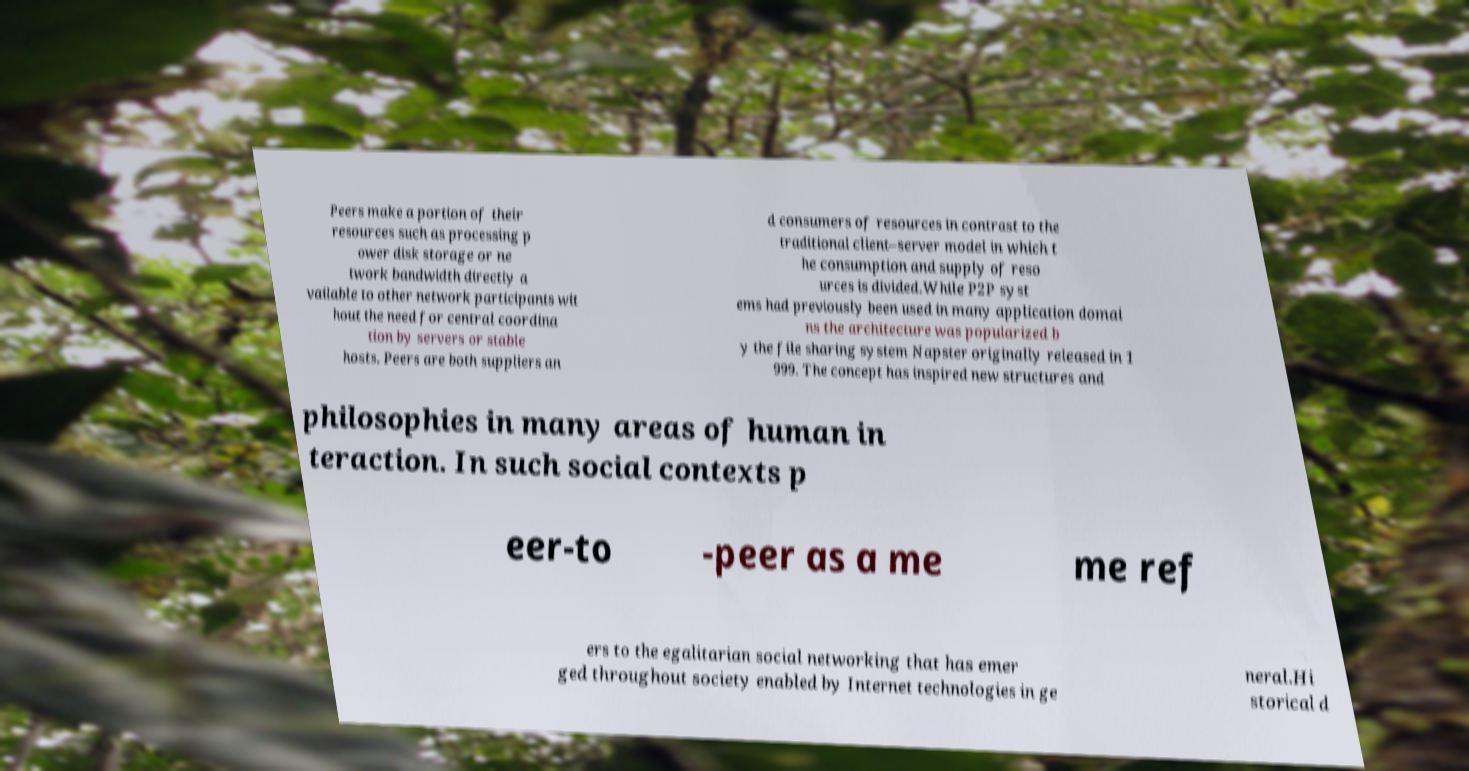There's text embedded in this image that I need extracted. Can you transcribe it verbatim? Peers make a portion of their resources such as processing p ower disk storage or ne twork bandwidth directly a vailable to other network participants wit hout the need for central coordina tion by servers or stable hosts. Peers are both suppliers an d consumers of resources in contrast to the traditional client–server model in which t he consumption and supply of reso urces is divided.While P2P syst ems had previously been used in many application domai ns the architecture was popularized b y the file sharing system Napster originally released in 1 999. The concept has inspired new structures and philosophies in many areas of human in teraction. In such social contexts p eer-to -peer as a me me ref ers to the egalitarian social networking that has emer ged throughout society enabled by Internet technologies in ge neral.Hi storical d 